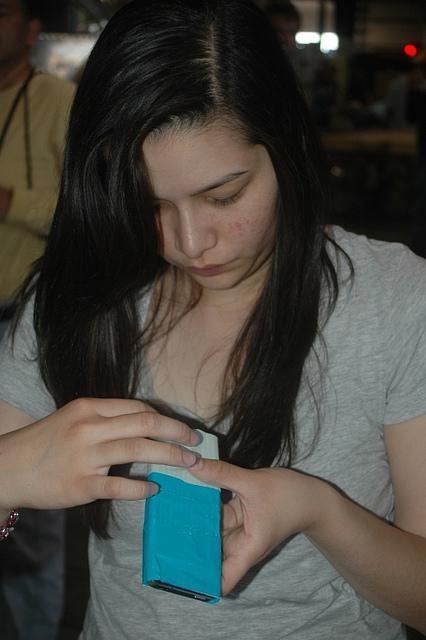How many people are there?
Give a very brief answer. 2. How many elephants are there?
Give a very brief answer. 0. 